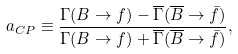<formula> <loc_0><loc_0><loc_500><loc_500>a _ { C P } \equiv \frac { \Gamma ( B \to f ) - \overline { \Gamma } ( \overline { B } \to \bar { f } ) } { \Gamma ( B \to f ) + \overline { \Gamma } ( \overline { B } \to \bar { f } ) } ,</formula> 